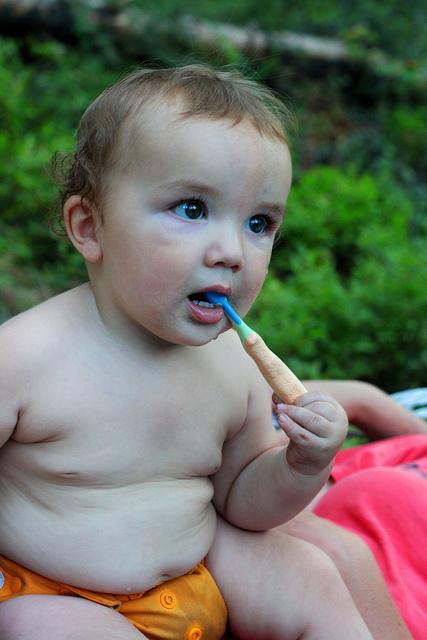Is the baby outside?
Write a very short answer. Yes. What is the boy holding in his left hand?
Give a very brief answer. Toothbrush. Does this baby have any teeth?
Be succinct. Yes. How many people are in the picture?
Be succinct. 1. What color are the babies eyes?
Give a very brief answer. Brown. What color are the babies clothes?
Short answer required. Orange. 